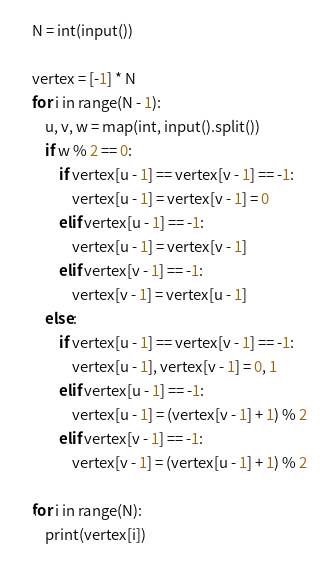Convert code to text. <code><loc_0><loc_0><loc_500><loc_500><_Python_>N = int(input())

vertex = [-1] * N
for i in range(N - 1):
    u, v, w = map(int, input().split())
    if w % 2 == 0:
        if vertex[u - 1] == vertex[v - 1] == -1:
            vertex[u - 1] = vertex[v - 1] = 0
        elif vertex[u - 1] == -1:
            vertex[u - 1] = vertex[v - 1]
        elif vertex[v - 1] == -1:
            vertex[v - 1] = vertex[u - 1]
    else:
        if vertex[u - 1] == vertex[v - 1] == -1:
            vertex[u - 1], vertex[v - 1] = 0, 1
        elif vertex[u - 1] == -1:
            vertex[u - 1] = (vertex[v - 1] + 1) % 2
        elif vertex[v - 1] == -1:
            vertex[v - 1] = (vertex[u - 1] + 1) % 2

for i in range(N):
    print(vertex[i])
</code> 